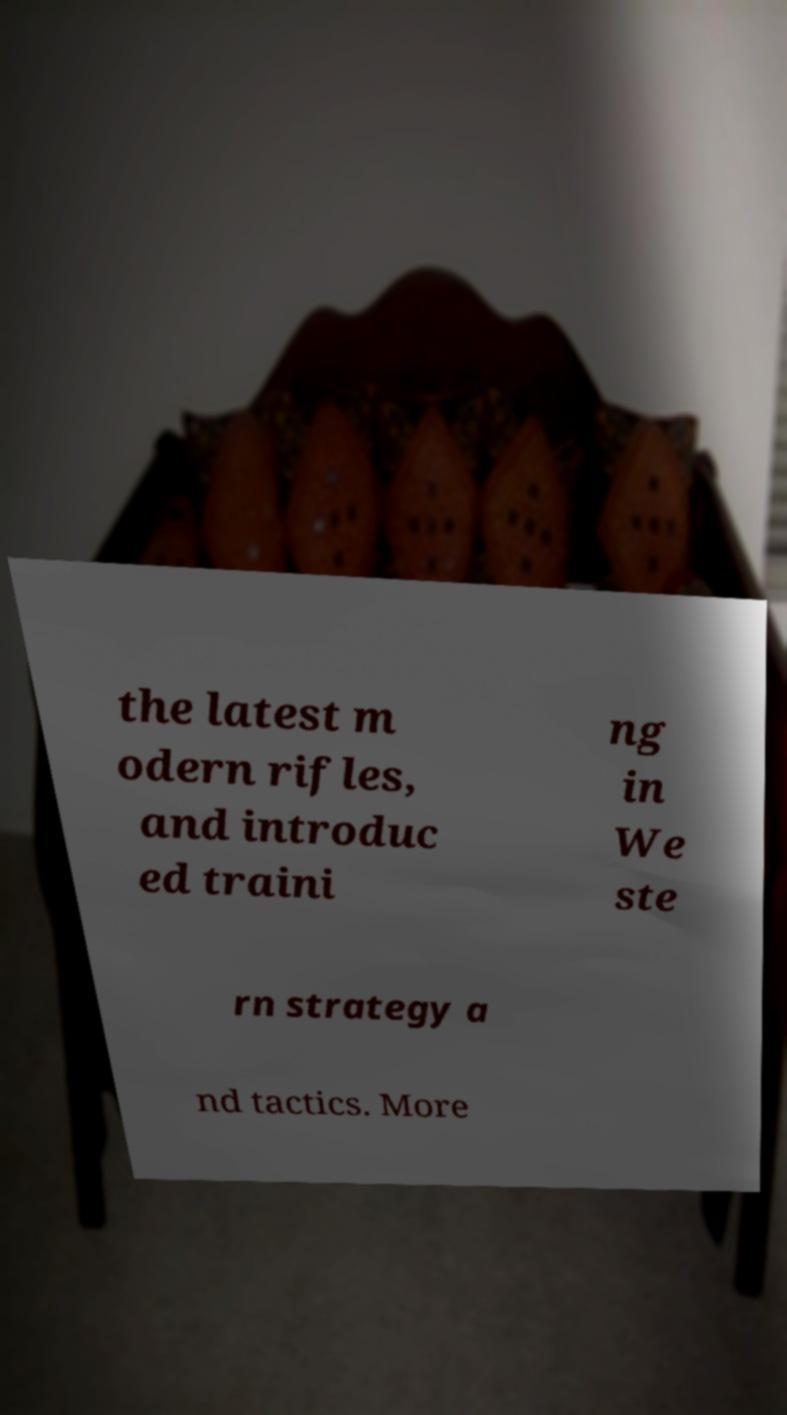Please identify and transcribe the text found in this image. the latest m odern rifles, and introduc ed traini ng in We ste rn strategy a nd tactics. More 